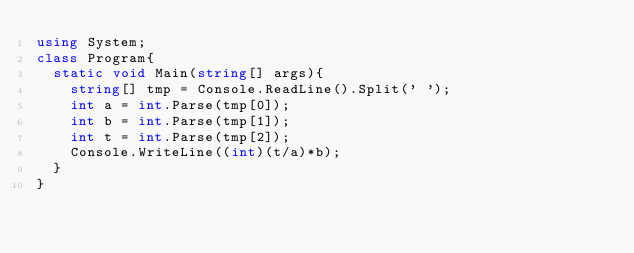<code> <loc_0><loc_0><loc_500><loc_500><_C#_>using System;
class Program{
  static void Main(string[] args){
    string[] tmp = Console.ReadLine().Split(' ');
    int a = int.Parse(tmp[0]);
    int b = int.Parse(tmp[1]);
    int t = int.Parse(tmp[2]);
    Console.WriteLine((int)(t/a)*b);
  }
}
</code> 